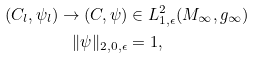<formula> <loc_0><loc_0><loc_500><loc_500>( C _ { l } , \psi _ { l } ) \to ( C , \psi ) & \in L ^ { 2 } _ { 1 , \epsilon } ( M _ { \infty } , g _ { \infty } ) \\ \| \psi \| _ { 2 , 0 , \epsilon } & = 1 ,</formula> 